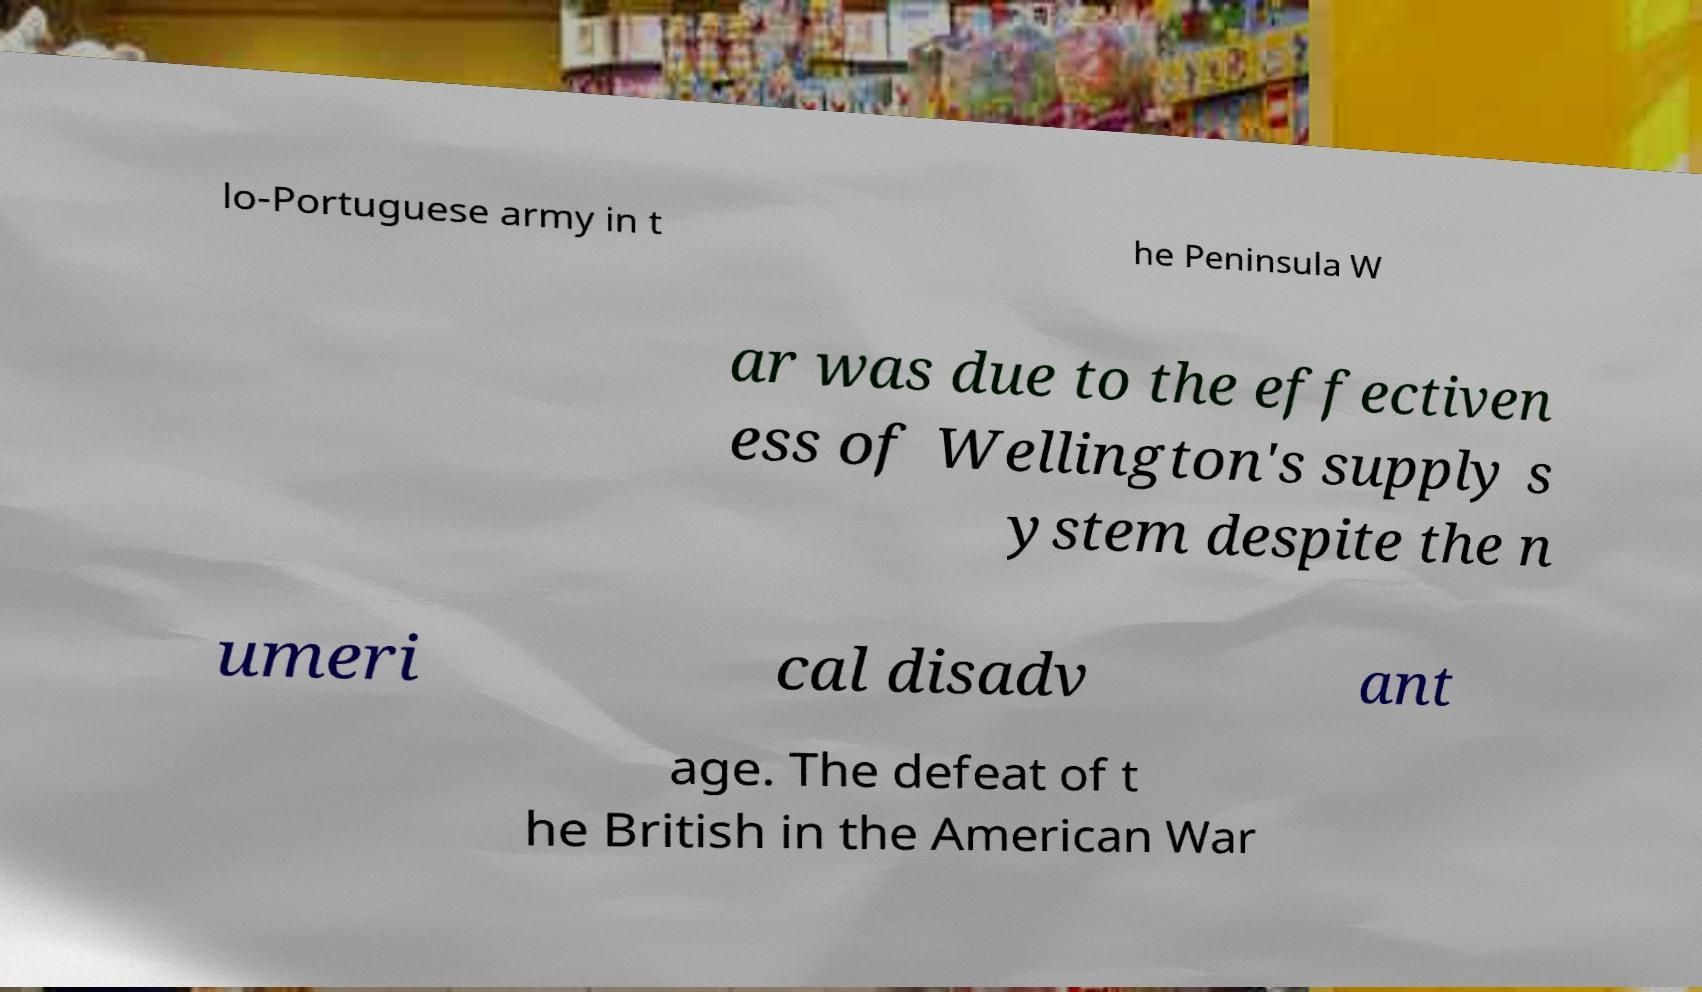Can you accurately transcribe the text from the provided image for me? lo-Portuguese army in t he Peninsula W ar was due to the effectiven ess of Wellington's supply s ystem despite the n umeri cal disadv ant age. The defeat of t he British in the American War 